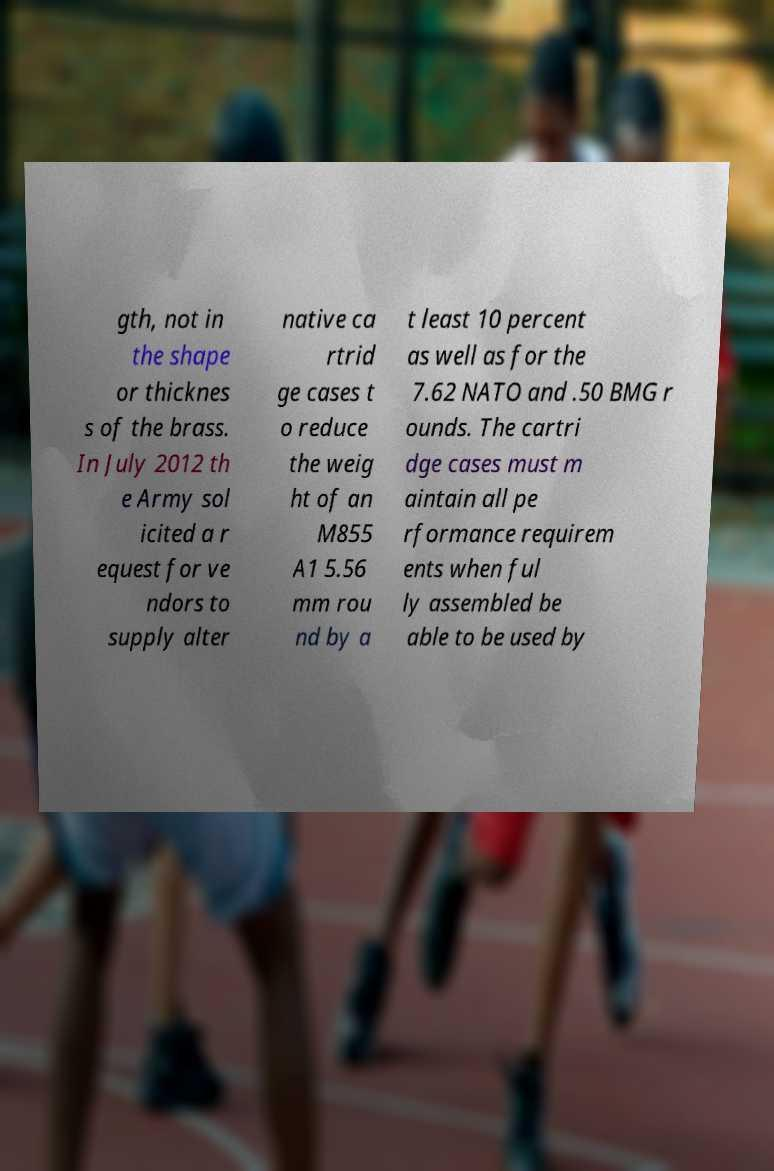What messages or text are displayed in this image? I need them in a readable, typed format. gth, not in the shape or thicknes s of the brass. In July 2012 th e Army sol icited a r equest for ve ndors to supply alter native ca rtrid ge cases t o reduce the weig ht of an M855 A1 5.56 mm rou nd by a t least 10 percent as well as for the 7.62 NATO and .50 BMG r ounds. The cartri dge cases must m aintain all pe rformance requirem ents when ful ly assembled be able to be used by 